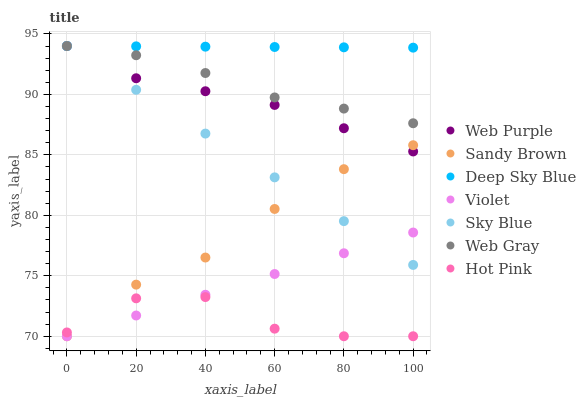Does Hot Pink have the minimum area under the curve?
Answer yes or no. Yes. Does Deep Sky Blue have the maximum area under the curve?
Answer yes or no. Yes. Does Web Purple have the minimum area under the curve?
Answer yes or no. No. Does Web Purple have the maximum area under the curve?
Answer yes or no. No. Is Deep Sky Blue the smoothest?
Answer yes or no. Yes. Is Hot Pink the roughest?
Answer yes or no. Yes. Is Web Purple the smoothest?
Answer yes or no. No. Is Web Purple the roughest?
Answer yes or no. No. Does Hot Pink have the lowest value?
Answer yes or no. Yes. Does Web Purple have the lowest value?
Answer yes or no. No. Does Sky Blue have the highest value?
Answer yes or no. Yes. Does Hot Pink have the highest value?
Answer yes or no. No. Is Hot Pink less than Sky Blue?
Answer yes or no. Yes. Is Deep Sky Blue greater than Violet?
Answer yes or no. Yes. Does Sandy Brown intersect Hot Pink?
Answer yes or no. Yes. Is Sandy Brown less than Hot Pink?
Answer yes or no. No. Is Sandy Brown greater than Hot Pink?
Answer yes or no. No. Does Hot Pink intersect Sky Blue?
Answer yes or no. No. 